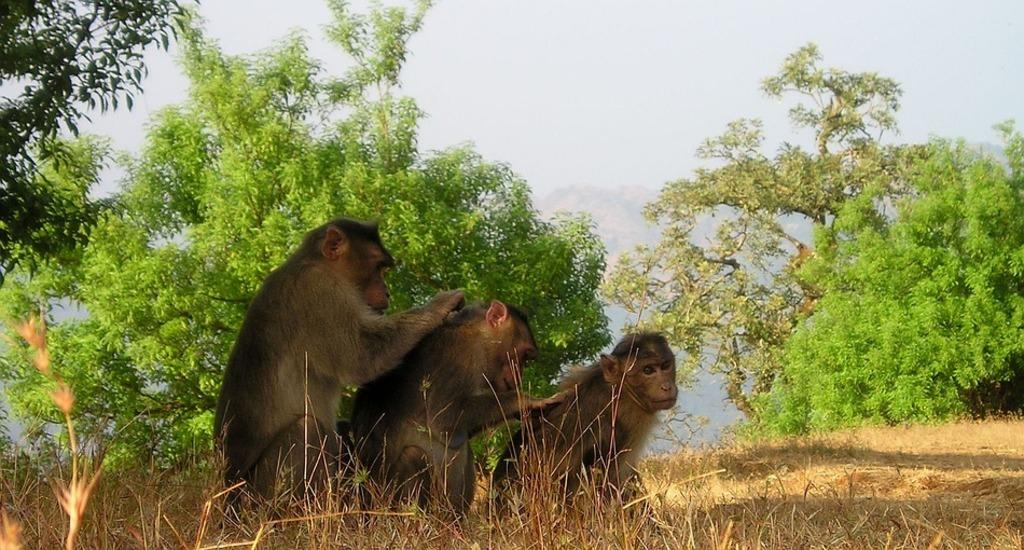How many monkeys are present in the image? There are three monkeys in the image. What colors are the monkeys in the image? The monkeys are in brown and black colors. What type of vegetation can be seen in the image? There is dry grass visible in the image. What is visible in the background of the image? The sky is visible in the image, and there are trees in green color. What type of iron is being used by the monkeys in the image? There is no iron present in the image; the monkeys are not using any tools or equipment. 